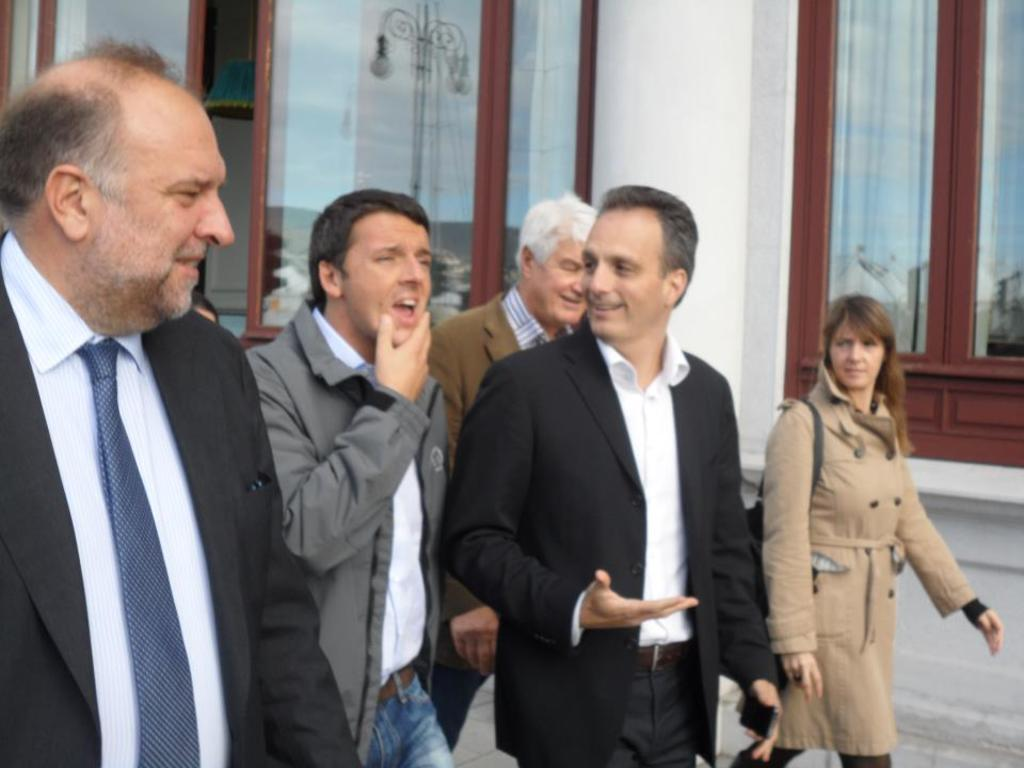What is happening with the group of people in the image? The people are walking on the ground in the image. What can be seen in the background of the image? There is a framed glass wall in the background of the image, along with other unspecified elements. How many straws are being used by the people in the image? There is no mention of straws in the image, so it cannot be determined how many straws are being used. 